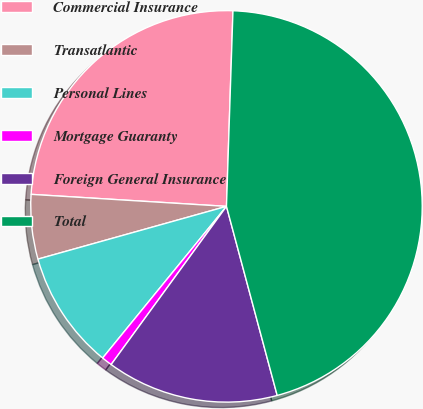<chart> <loc_0><loc_0><loc_500><loc_500><pie_chart><fcel>Commercial Insurance<fcel>Transatlantic<fcel>Personal Lines<fcel>Mortgage Guaranty<fcel>Foreign General Insurance<fcel>Total<nl><fcel>24.55%<fcel>5.32%<fcel>9.76%<fcel>0.87%<fcel>14.2%<fcel>45.3%<nl></chart> 